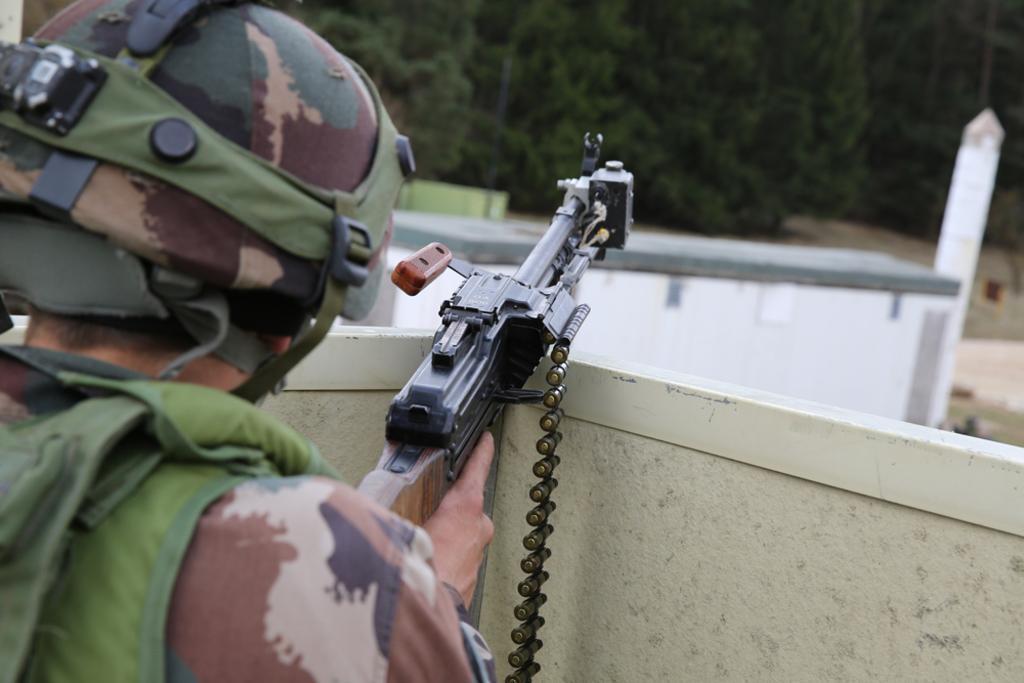Can you describe this image briefly? In this image we can see a person wearing helmet is holding a gun. In the back there is a wall. Also there are trees. 